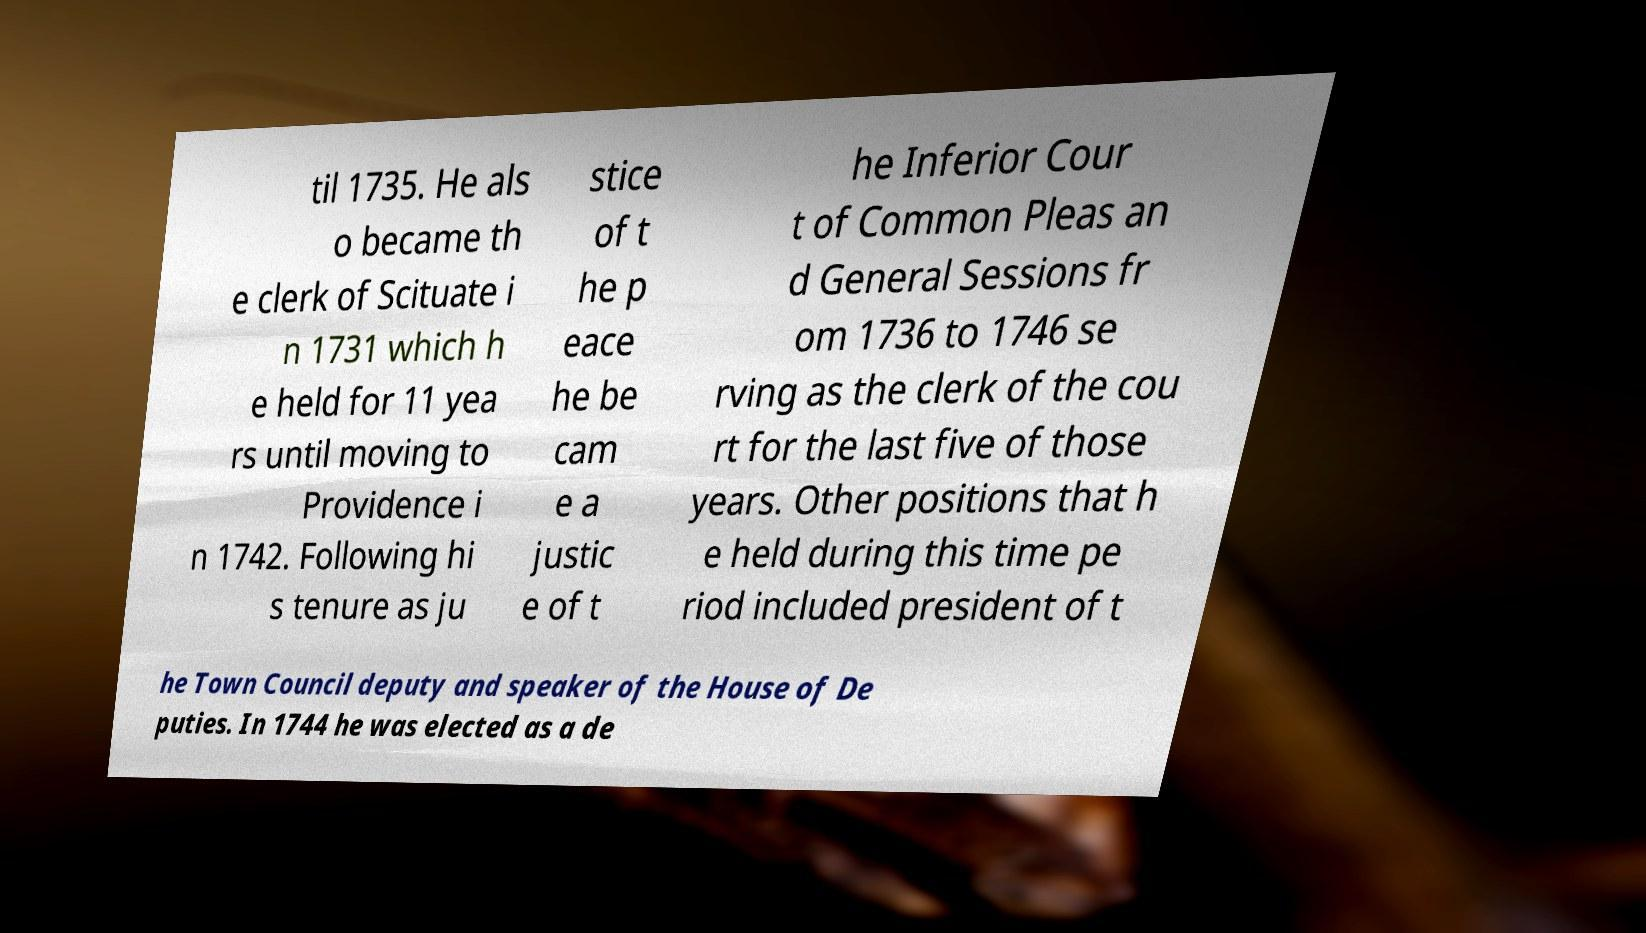There's text embedded in this image that I need extracted. Can you transcribe it verbatim? til 1735. He als o became th e clerk of Scituate i n 1731 which h e held for 11 yea rs until moving to Providence i n 1742. Following hi s tenure as ju stice of t he p eace he be cam e a justic e of t he Inferior Cour t of Common Pleas an d General Sessions fr om 1736 to 1746 se rving as the clerk of the cou rt for the last five of those years. Other positions that h e held during this time pe riod included president of t he Town Council deputy and speaker of the House of De puties. In 1744 he was elected as a de 